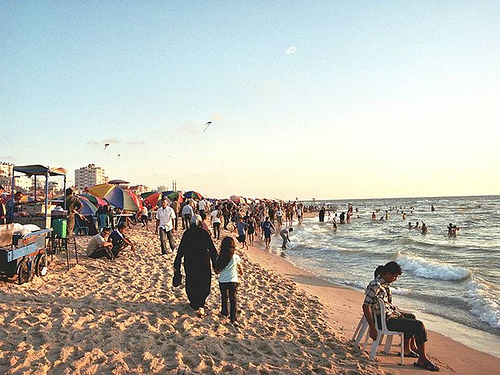Describe the activities that are happening on the beach? The beach scene is vibrant and full of activity, with people swimming in the ocean, sunbathing, walking along the shore, and some are playing near the water's edge. There's also a noticeable presence of various colorful umbrellas and beach gear scattered around, adding a lively ambiance to the setting. 